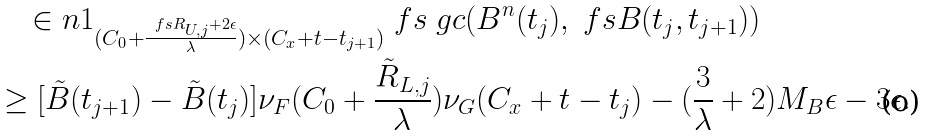<formula> <loc_0><loc_0><loc_500><loc_500>& \quad \in n { 1 _ { ( C _ { 0 } + \frac { \ f s R _ { U , j } + 2 \epsilon } { \lambda } ) \times ( C _ { x } + t - t _ { j + 1 } ) } } { \ f s \ g c ( B ^ { n } ( t _ { j } ) , \ f s B ( t _ { j } , t _ { j + 1 } ) ) } \\ & \geq [ \tilde { B } ( t _ { j + 1 } ) - \tilde { B } ( t _ { j } ) ] \nu _ { F } ( C _ { 0 } + \frac { \tilde { R } _ { L , j } } { \lambda } ) \nu _ { G } ( C _ { x } + t - t _ { j } ) - ( \frac { 3 } { \lambda } + 2 ) M _ { B } \epsilon - 3 \epsilon .</formula> 